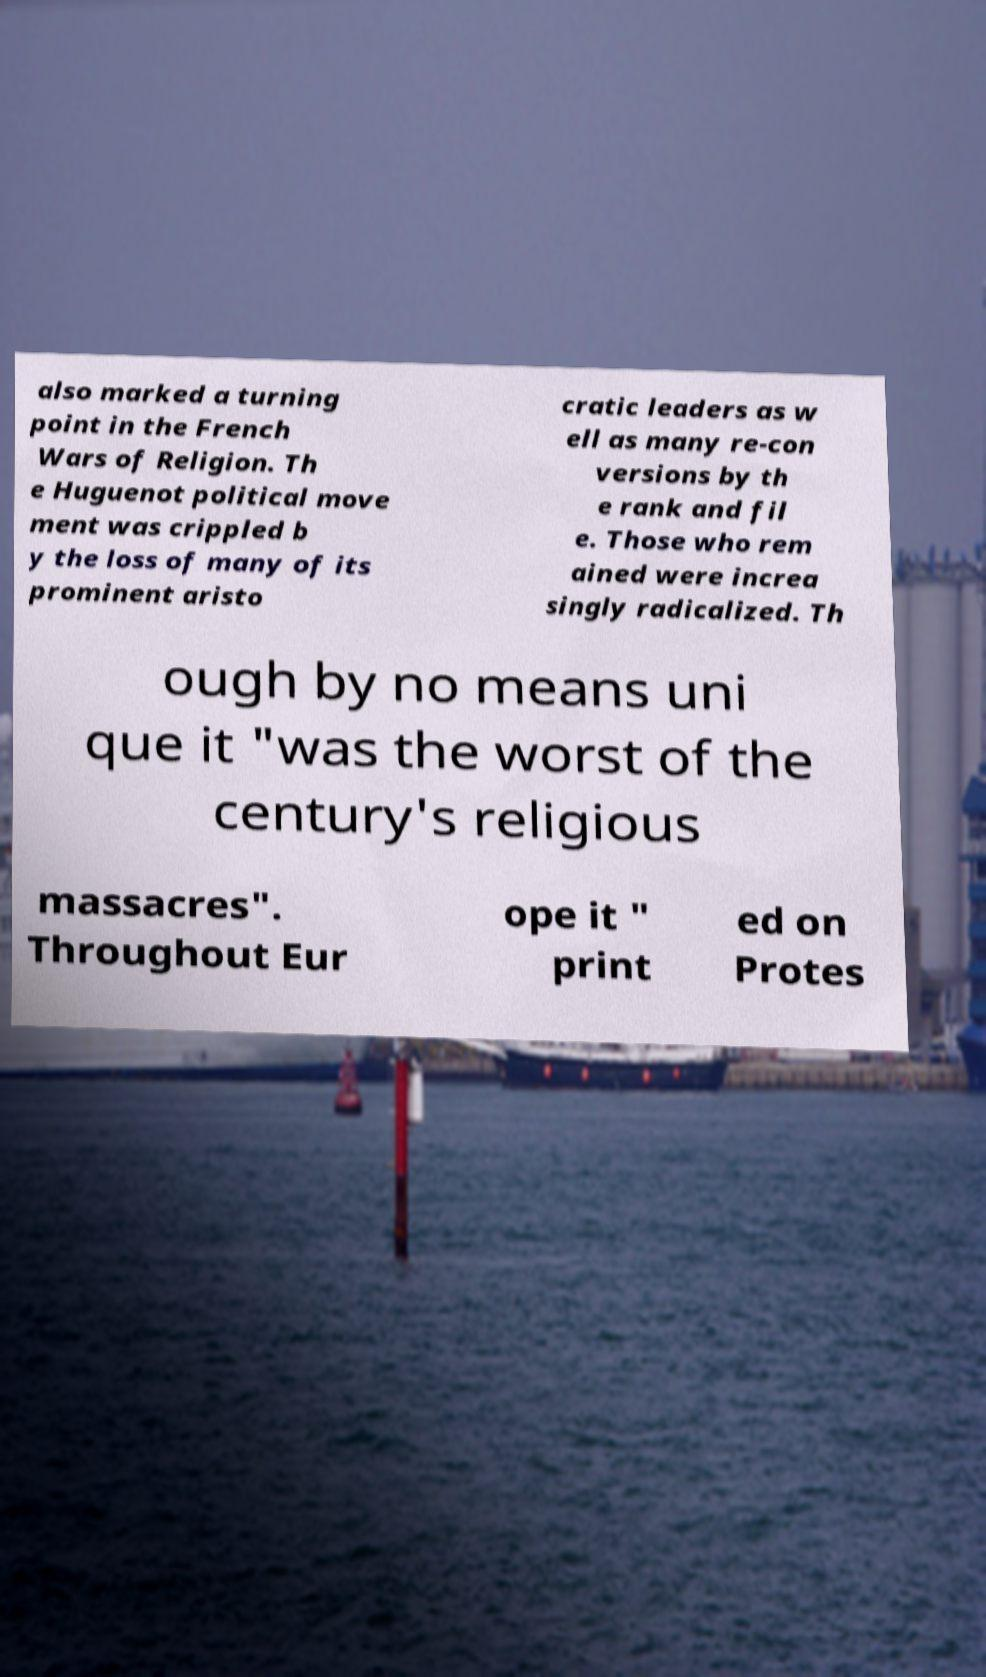Can you read and provide the text displayed in the image?This photo seems to have some interesting text. Can you extract and type it out for me? also marked a turning point in the French Wars of Religion. Th e Huguenot political move ment was crippled b y the loss of many of its prominent aristo cratic leaders as w ell as many re-con versions by th e rank and fil e. Those who rem ained were increa singly radicalized. Th ough by no means uni que it "was the worst of the century's religious massacres". Throughout Eur ope it " print ed on Protes 